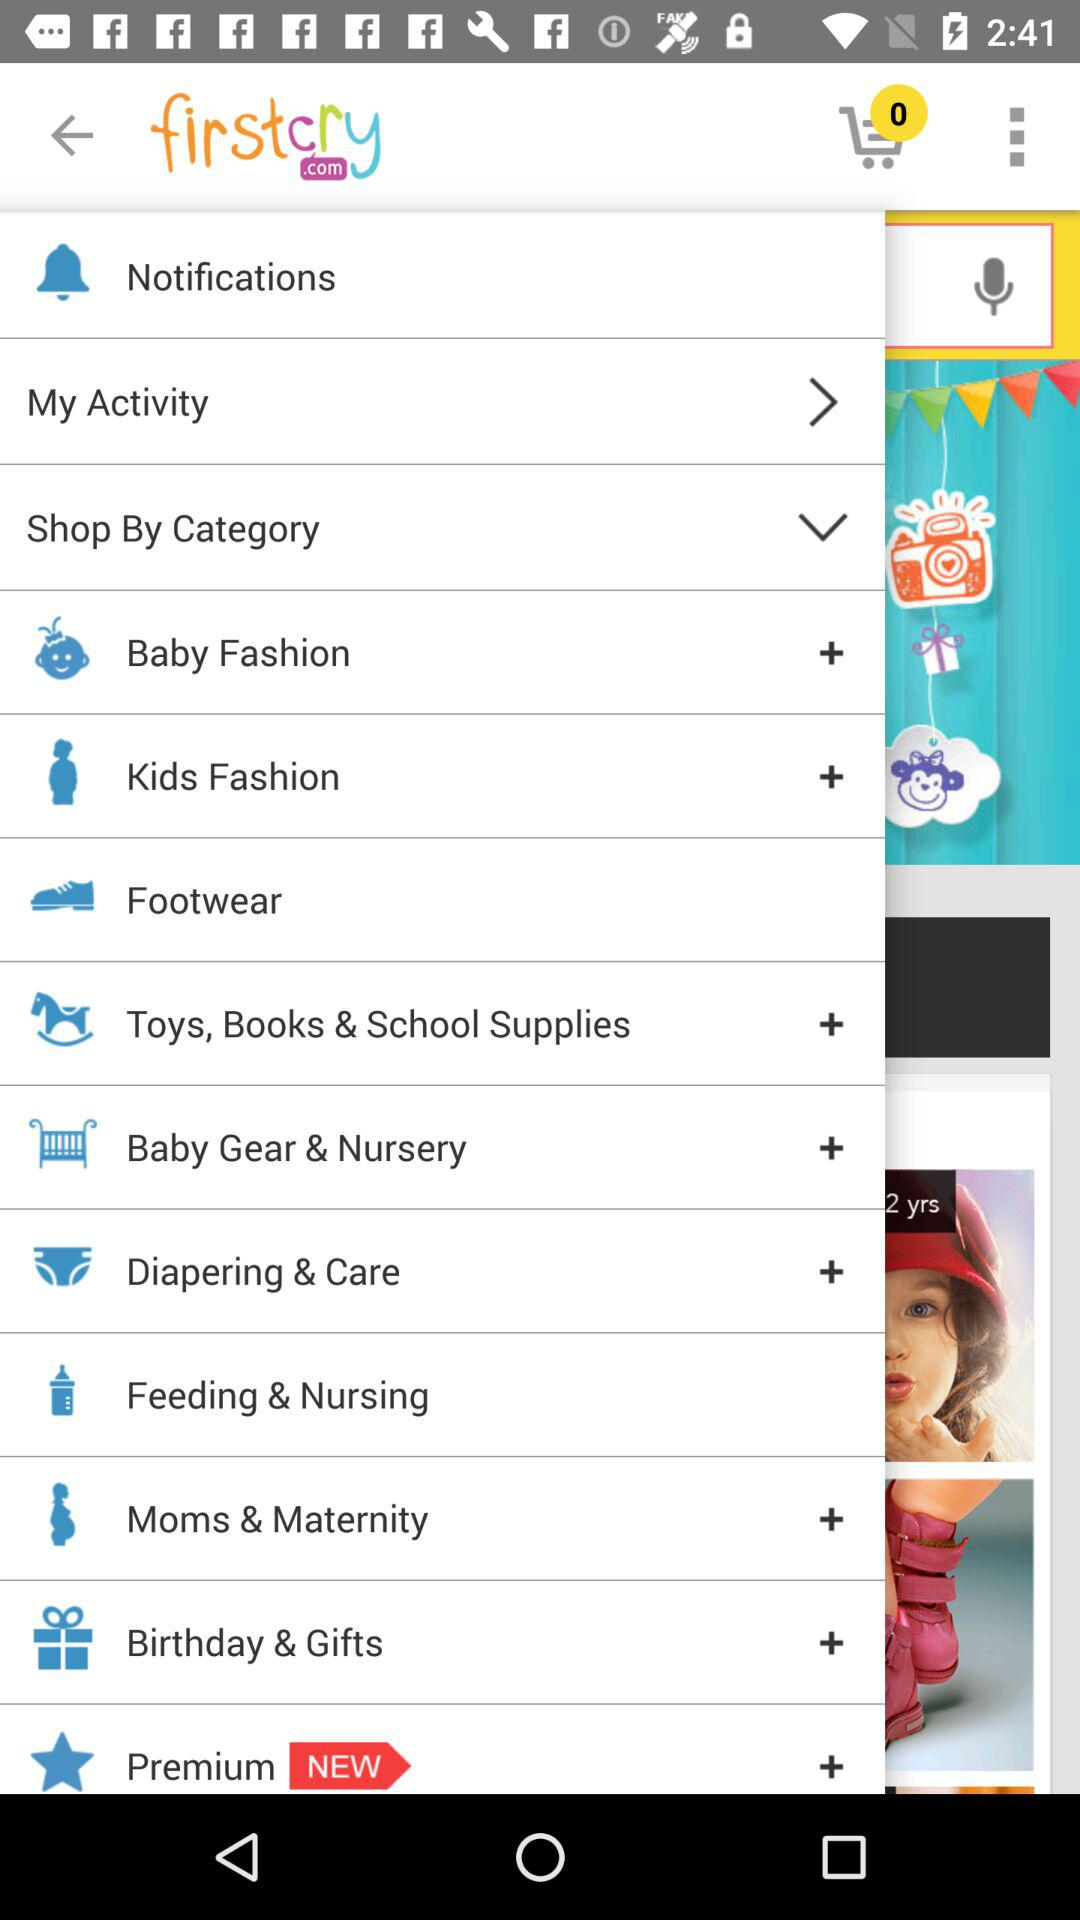Which item is available as new? The item that is available as new is "Premium". 